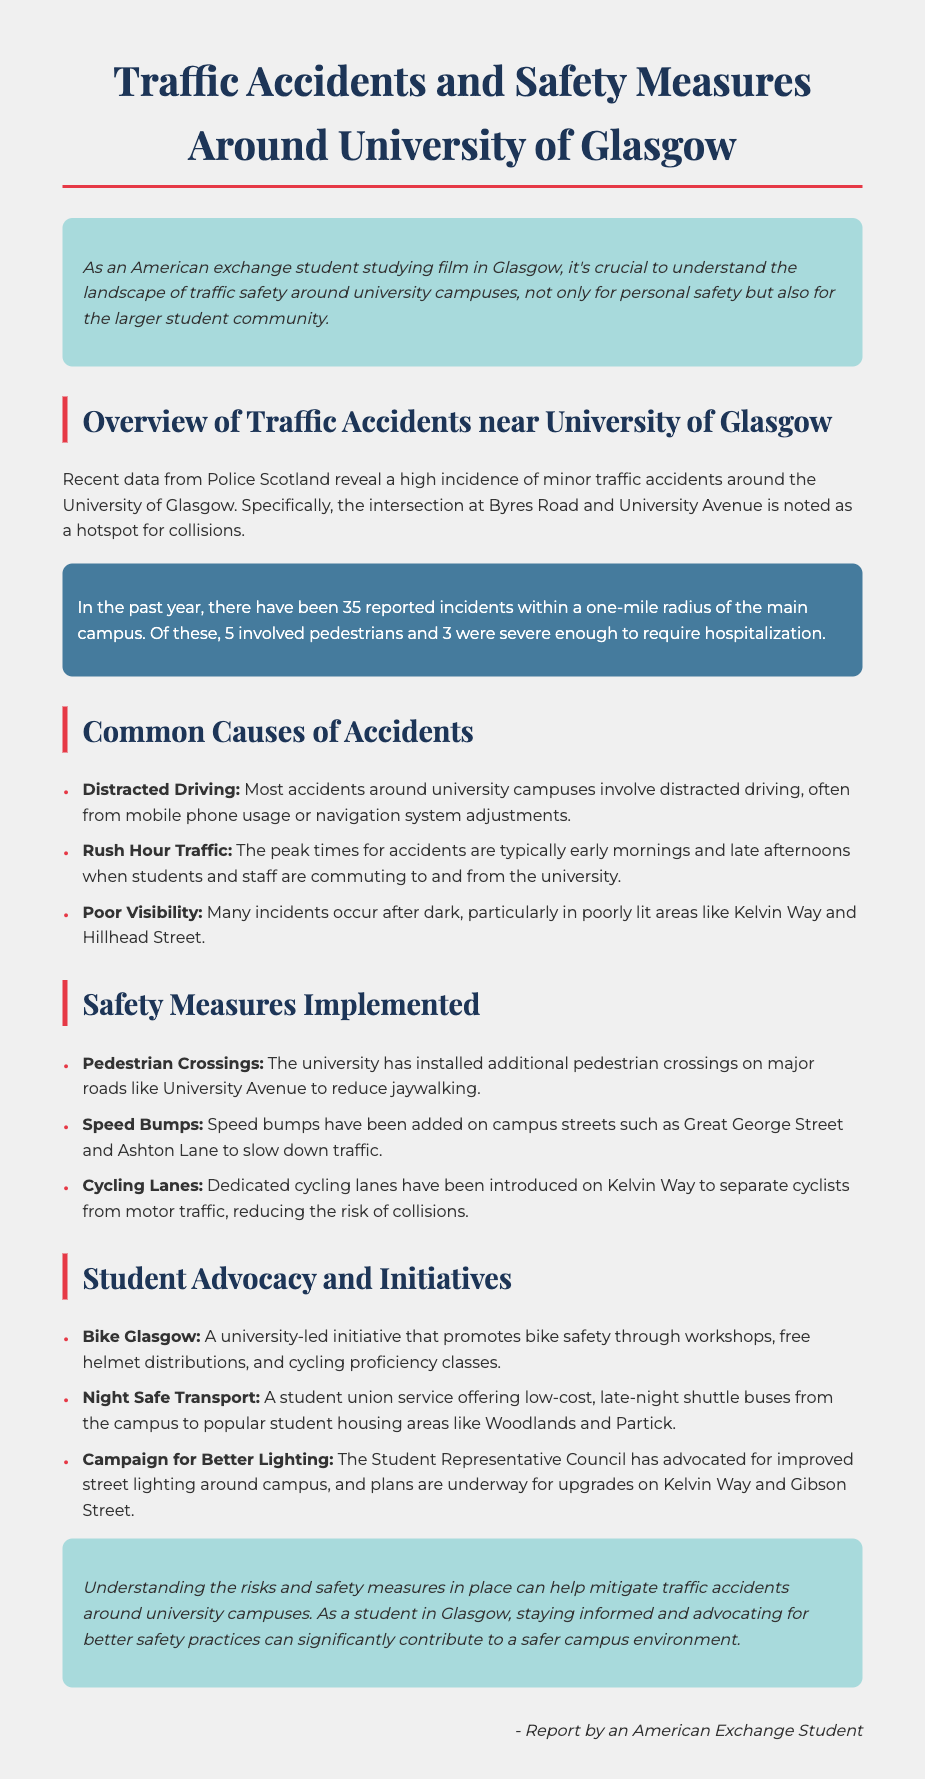What is the hotspot intersection for collisions? The document mentions that the intersection at Byres Road and University Avenue is noted as a hotspot for collisions.
Answer: Byres Road and University Avenue How many reported incidents were there within a one-mile radius of the campus? The report states that there have been 35 reported incidents within a one-mile radius of the main campus.
Answer: 35 What time of day sees peak accidents at the university? The report indicates that peak times for accidents are early mornings and late afternoons.
Answer: Early mornings and late afternoons How many accidents involved pedestrians? The document specifies that 5 out of the total reported incidents involved pedestrians.
Answer: 5 What initiative promotes bike safety at the university? The report mentions "Bike Glasgow" as the initiative that promotes bike safety.
Answer: Bike Glasgow What safety measure is being taken to slow down traffic on campus streets? The document lists speed bumps as a safety measure added on campus streets to slow down traffic.
Answer: Speed bumps Which streets are identified as poorly lit areas contributing to accidents? The report indicates that Kelvin Way and Hillhead Street are poorly lit areas where many incidents occur.
Answer: Kelvin Way and Hillhead Street What does the Night Safe Transport initiative offer? The document states that it offers low-cost, late-night shuttle buses from the campus to popular student housing areas.
Answer: Low-cost, late-night shuttle buses What is a proposed improvement by the Student Representative Council? The report notes that the Student Representative Council has advocated for improved street lighting around campus.
Answer: Improved street lighting 